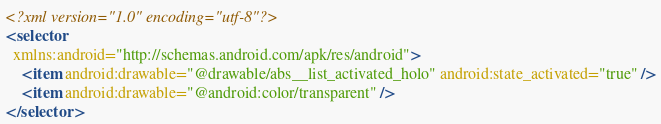Convert code to text. <code><loc_0><loc_0><loc_500><loc_500><_XML_><?xml version="1.0" encoding="utf-8"?>
<selector
  xmlns:android="http://schemas.android.com/apk/res/android">
    <item android:drawable="@drawable/abs__list_activated_holo" android:state_activated="true" />
    <item android:drawable="@android:color/transparent" />
</selector>
</code> 